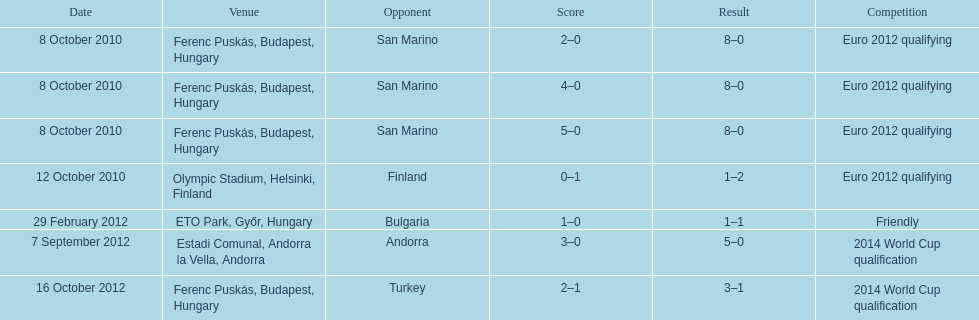How many non-qualifying games did he score in? 1. 